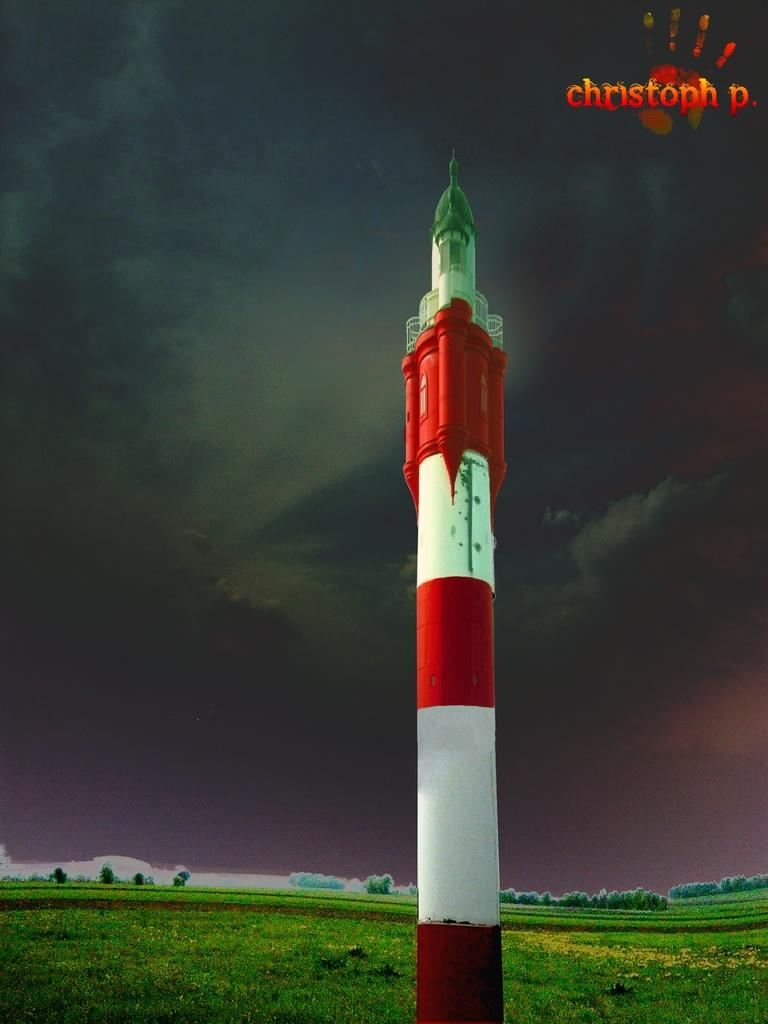What is the main subject in the center of the image? There is a rocket in the center of the image. What type of vegetation can be seen at the bottom of the image? There are trees at the bottom of the image. What is the surface visible in the image? There is ground visible in the image. What is written or depicted at the top of the image? There is some text at the top of the image. What is the result of the rocket's launch in the image? A: Smoke is visible in the sky, indicating that the rocket has been launched. What type of vegetable is growing next to the rocket in the image? There are no vegetables present in the image; it features a rocket, trees, ground, text, and smoke. 